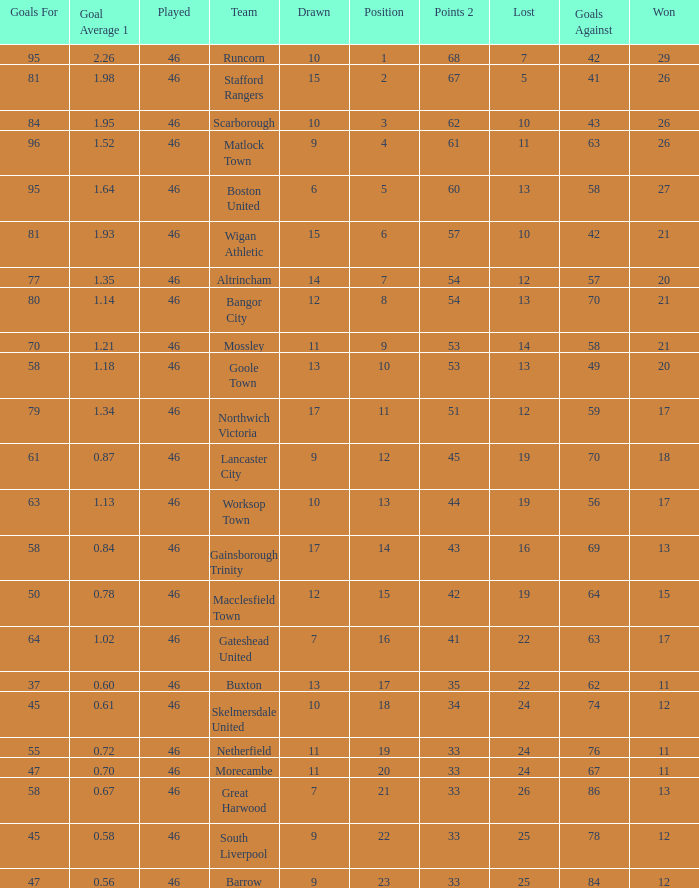Help me parse the entirety of this table. {'header': ['Goals For', 'Goal Average 1', 'Played', 'Team', 'Drawn', 'Position', 'Points 2', 'Lost', 'Goals Against', 'Won'], 'rows': [['95', '2.26', '46', 'Runcorn', '10', '1', '68', '7', '42', '29'], ['81', '1.98', '46', 'Stafford Rangers', '15', '2', '67', '5', '41', '26'], ['84', '1.95', '46', 'Scarborough', '10', '3', '62', '10', '43', '26'], ['96', '1.52', '46', 'Matlock Town', '9', '4', '61', '11', '63', '26'], ['95', '1.64', '46', 'Boston United', '6', '5', '60', '13', '58', '27'], ['81', '1.93', '46', 'Wigan Athletic', '15', '6', '57', '10', '42', '21'], ['77', '1.35', '46', 'Altrincham', '14', '7', '54', '12', '57', '20'], ['80', '1.14', '46', 'Bangor City', '12', '8', '54', '13', '70', '21'], ['70', '1.21', '46', 'Mossley', '11', '9', '53', '14', '58', '21'], ['58', '1.18', '46', 'Goole Town', '13', '10', '53', '13', '49', '20'], ['79', '1.34', '46', 'Northwich Victoria', '17', '11', '51', '12', '59', '17'], ['61', '0.87', '46', 'Lancaster City', '9', '12', '45', '19', '70', '18'], ['63', '1.13', '46', 'Worksop Town', '10', '13', '44', '19', '56', '17'], ['58', '0.84', '46', 'Gainsborough Trinity', '17', '14', '43', '16', '69', '13'], ['50', '0.78', '46', 'Macclesfield Town', '12', '15', '42', '19', '64', '15'], ['64', '1.02', '46', 'Gateshead United', '7', '16', '41', '22', '63', '17'], ['37', '0.60', '46', 'Buxton', '13', '17', '35', '22', '62', '11'], ['45', '0.61', '46', 'Skelmersdale United', '10', '18', '34', '24', '74', '12'], ['55', '0.72', '46', 'Netherfield', '11', '19', '33', '24', '76', '11'], ['47', '0.70', '46', 'Morecambe', '11', '20', '33', '24', '67', '11'], ['58', '0.67', '46', 'Great Harwood', '7', '21', '33', '26', '86', '13'], ['45', '0.58', '46', 'South Liverpool', '9', '22', '33', '25', '78', '12'], ['47', '0.56', '46', 'Barrow', '9', '23', '33', '25', '84', '12']]} How many times did the Lancaster City team play? 1.0. 